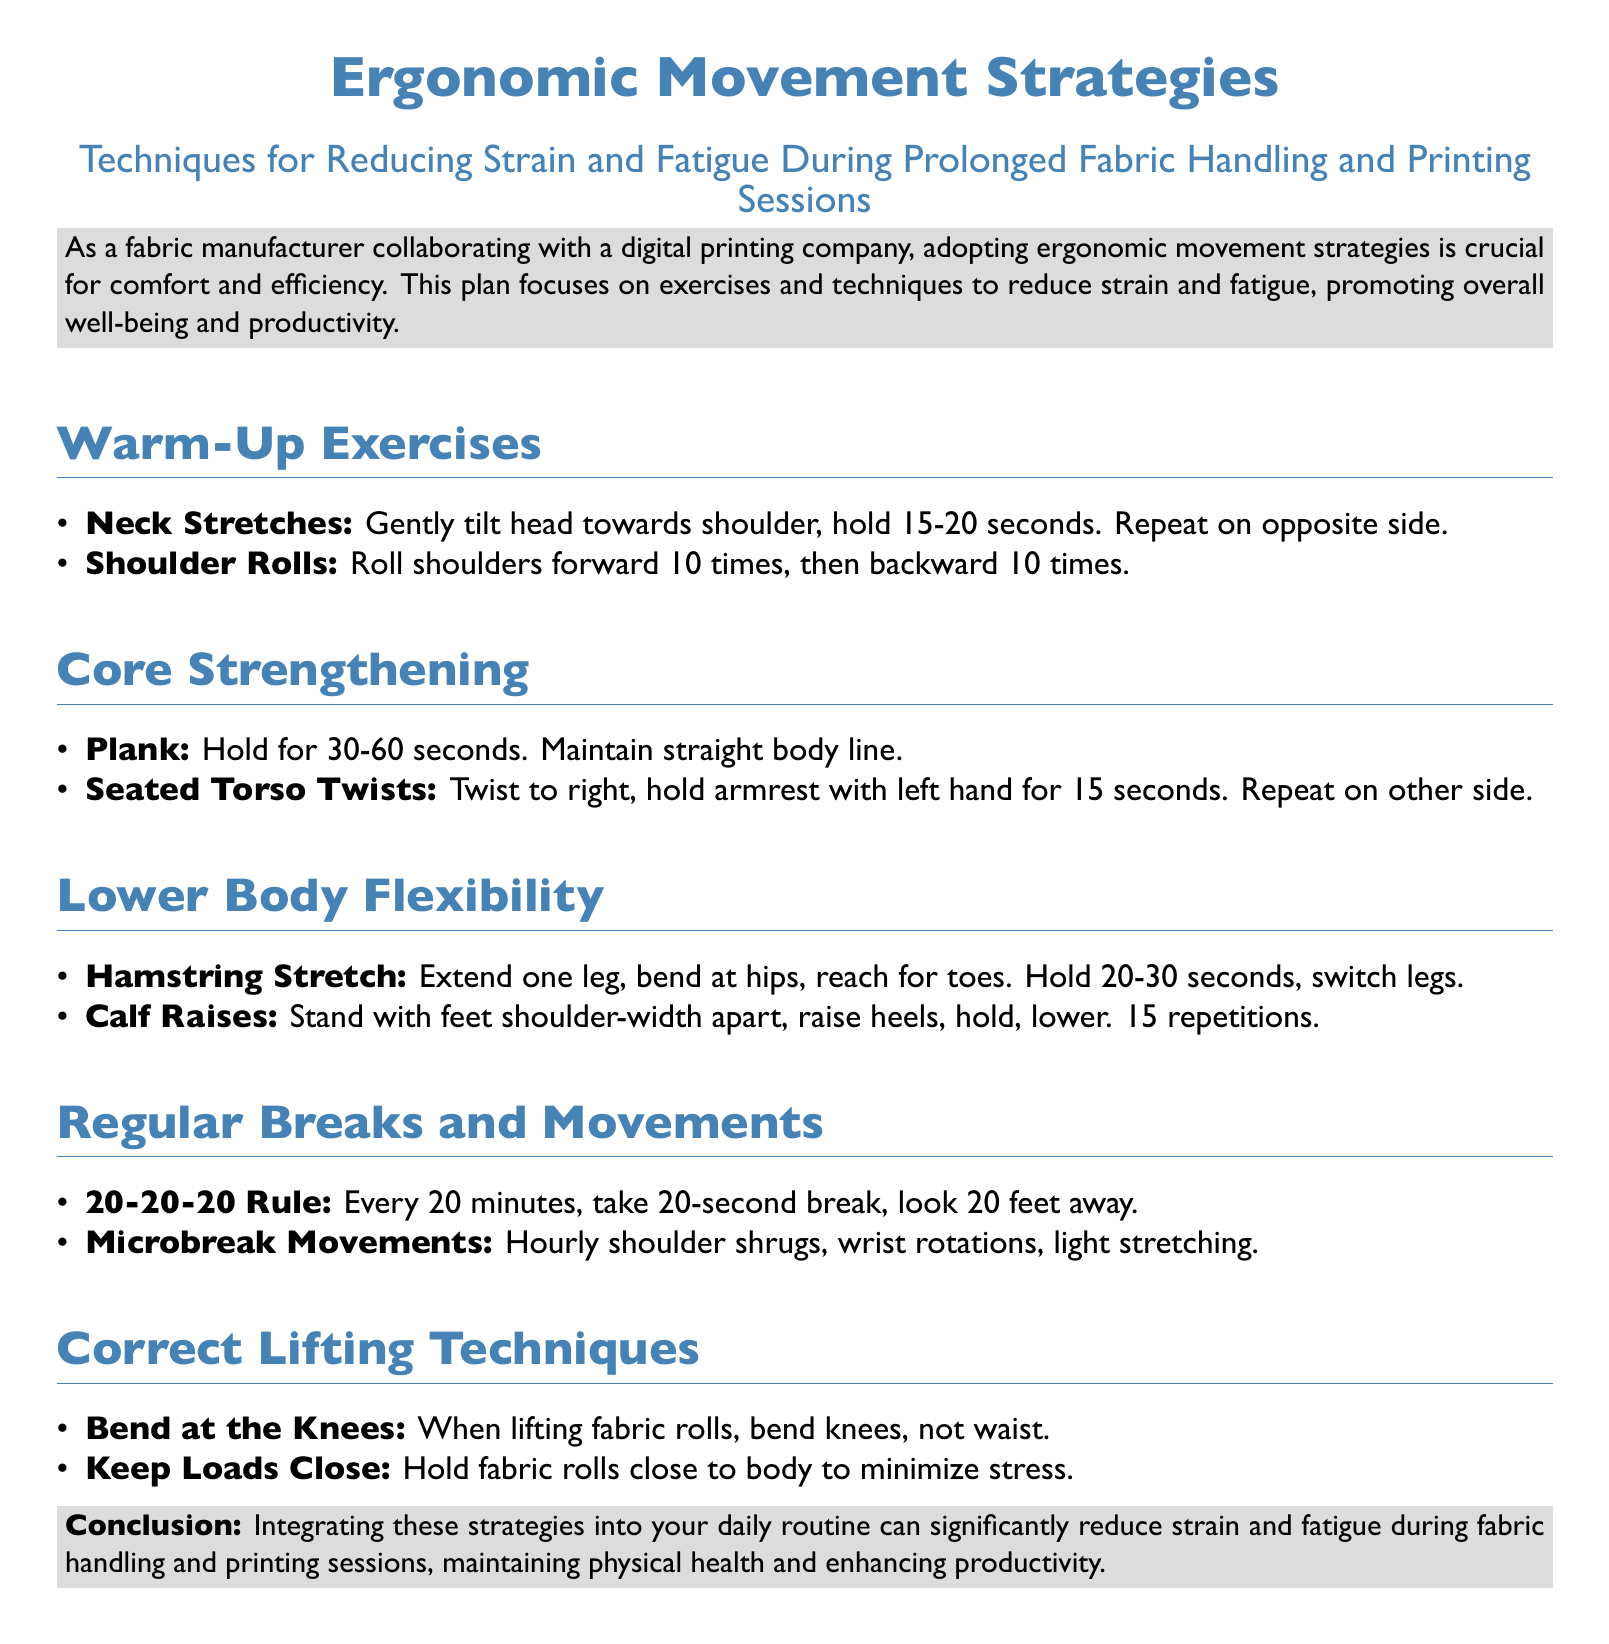What is the title of the document? The title of the document is the main heading found at the top.
Answer: Ergonomic Movement Strategies What is the main focus of the document? The main focus is stated in the subtitle, highlighting the document's purpose.
Answer: Reducing Strain and Fatigue During Prolonged Fabric Handling and Printing Sessions How long should the plank exercise be held? The duration for holding the plank exercise is mentioned in the Core Strengthening section.
Answer: 30-60 seconds What rule is suggested for taking breaks? The guideline for breaks is outlined in the Regular Breaks and Movements section.
Answer: 20-20-20 Rule What technique is recommended for lifting fabric rolls? The advice on lifting fabric rolls is specified under Correct Lifting Techniques.
Answer: Bend at the Knees How many repetitions of calf raises are suggested? The number of repetitions for calf raises is provided in the Lower Body Flexibility section.
Answer: 15 repetitions What is the conclusion regarding the integration of strategies? The conclusion summarizes the overall benefit of the strategies discussed.
Answer: Significantly reduce strain and fatigue What is one of the exercises included in the Warm-Up section? The Warm-Up Exercises section lists various exercises.
Answer: Neck Stretches 